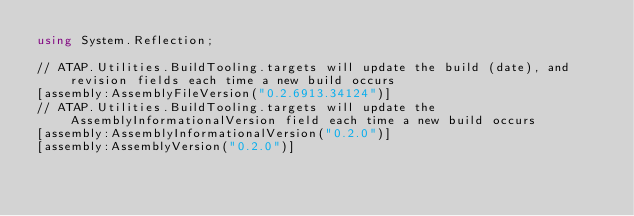Convert code to text. <code><loc_0><loc_0><loc_500><loc_500><_C#_>using System.Reflection;

// ATAP.Utilities.BuildTooling.targets will update the build (date), and revision fields each time a new build occurs
[assembly:AssemblyFileVersion("0.2.6913.34124")]
// ATAP.Utilities.BuildTooling.targets will update the AssemblyInformationalVersion field each time a new build occurs
[assembly:AssemblyInformationalVersion("0.2.0")]
[assembly:AssemblyVersion("0.2.0")]
</code> 